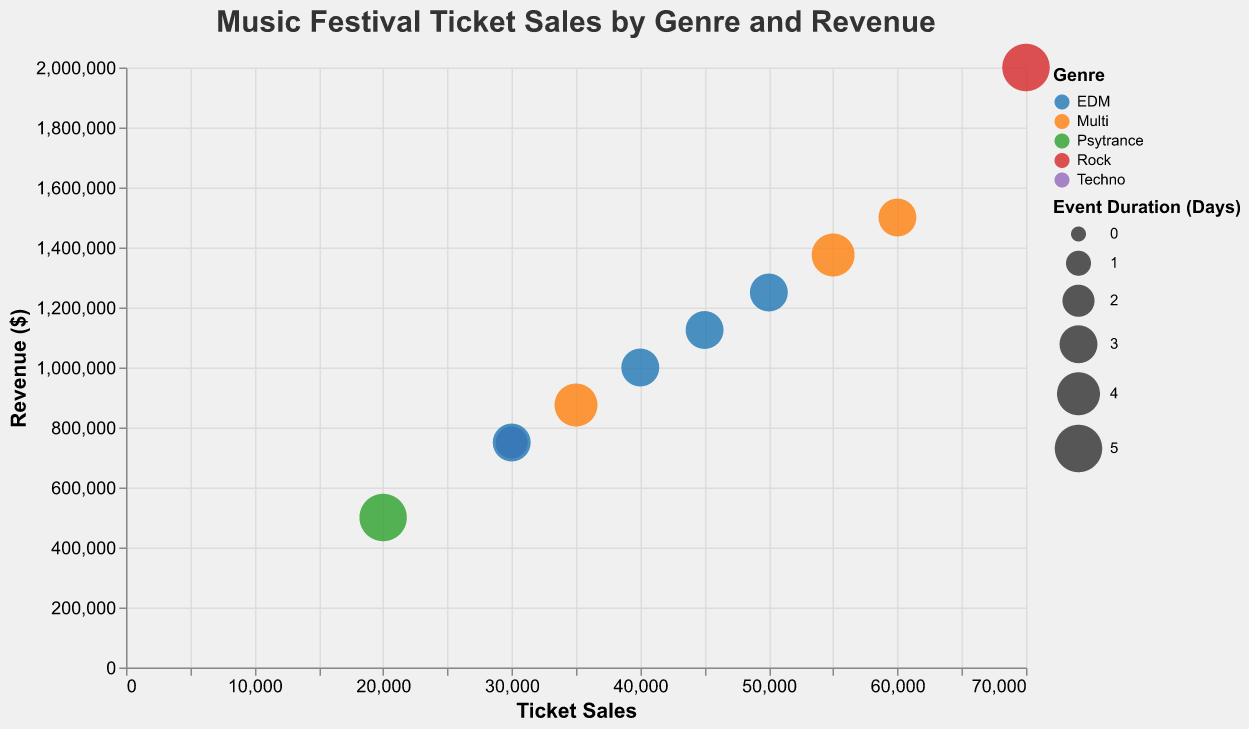What is the title of the chart? The title of the chart can be found at the top and is usually in a larger font size and distinct from other text elements. The title here reads "Music Festival Ticket Sales by Genre and Revenue".
Answer: Music Festival Ticket Sales by Genre and Revenue Which festival has the highest ticket sales? Locate the festival with the highest position on the x-axis as it represents ticket sales. Glastonbury is positioned furthest to the right with 70,000 ticket sales.
Answer: Glastonbury Which genre appears to have the most festivals? Look at the colors representing different genres in the chart. EDM appears multiple times, including Tomorrowland, Ultra Music Festival, Electric Daisy Carnival, and Creamfields. The genre EDM is indicated by the color associated with it in the legend.
Answer: EDM What is the revenue for Tomorrowland? Hover over or locate the bubble representing Tomorrowland. The tooltip or bubble position on the y-axis provides the revenue, which is $1,000,000.
Answer: $1,000,000 Which festival has the longest event duration? Check the size of the bubbles, as larger bubbles represent a longer event duration. Glastonbury and Ozora Festival have the largest bubbles, representing 5 days.
Answer: Glastonbury and Ozora Festival What is the difference in revenue between Coachella and Ultra Music Festival? Locate Coachella and Ultra Music Festival on the chart, find their revenues ($1,500,000 and $1,250,000, respectively), and calculate the difference: $1,500,000 - $1,250,000 = $250,000.
Answer: $250,000 Which festivals are located in the USA, and how do their ticket sales compare? Identify the bubbles for festivals in the USA by looking at the "Location" field in the tooltip. The USA festivals are Coachella, Ultra Music Festival, Electric Daisy Carnival, and Lollapalooza. Compare their ticket sales: Coachella (60,000), Ultra Music Festival (50,000), Electric Daisy Carnival (45,000), and Lollapalooza (55,000). Coachella has the highest ticket sales, and Electric Daisy Carnival has the lowest.
Answer: Coachella has the highest, Electric Daisy Carnival has the lowest How does the ticket sales of Tomorrowland compare to Creamfields? Locate the bubbles for Tomorrowland and Creamfields. Tomorrowland's ticket sales are 40,000, and Creamfields' are 30,000. Compare the two numbers, noting that Tomorrowland has 10,000 more ticket sales than Creamfields.
Answer: Tomorrowland has more What is the average revenue of festivals headlined by DJs from the genre "Multi"? Identify festivals with the "Multi" genre: Coachella ($1,500,000), Lollapalooza ($1,375,000), and Exit Festival ($875,000). Sum the revenues and divide by the number of festivals: ($1,500,000 + $1,375,000 + $875,000) / 3 = $1,250,000.
Answer: $1,250,000 What is the relationship between event duration and ticket sales? Observe the size of the bubbles corresponding to the event duration and their position on the x-axis. There seems to be no direct correlation as festivals with longer durations do not always have higher ticket sales. For instance, Ozora Festival has a long duration but lower ticket sales compared to Coachella with a shorter duration.
Answer: No direct relationship 